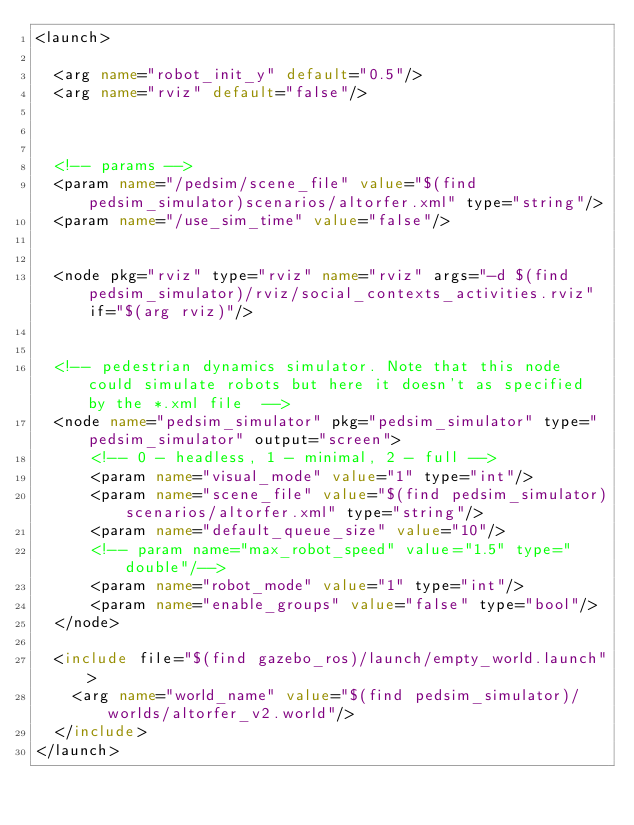Convert code to text. <code><loc_0><loc_0><loc_500><loc_500><_XML_><launch>

  <arg name="robot_init_y" default="0.5"/>
  <arg name="rviz" default="false"/>
  
  

  <!-- params -->
  <param name="/pedsim/scene_file" value="$(find pedsim_simulator)scenarios/altorfer.xml" type="string"/>
  <param name="/use_sim_time" value="false"/>


  <node pkg="rviz" type="rviz" name="rviz" args="-d $(find pedsim_simulator)/rviz/social_contexts_activities.rviz" if="$(arg rviz)"/>


  <!-- pedestrian dynamics simulator. Note that this node could simulate robots but here it doesn't as specified by the *.xml file  -->
  <node name="pedsim_simulator" pkg="pedsim_simulator" type="pedsim_simulator" output="screen">
      <!-- 0 - headless, 1 - minimal, 2 - full -->
      <param name="visual_mode" value="1" type="int"/>
      <param name="scene_file" value="$(find pedsim_simulator)scenarios/altorfer.xml" type="string"/>
      <param name="default_queue_size" value="10"/>
      <!-- param name="max_robot_speed" value="1.5" type="double"/-->
      <param name="robot_mode" value="1" type="int"/>
      <param name="enable_groups" value="false" type="bool"/>
  </node>

  <include file="$(find gazebo_ros)/launch/empty_world.launch">
    <arg name="world_name" value="$(find pedsim_simulator)/worlds/altorfer_v2.world"/>
  </include>
</launch>
</code> 